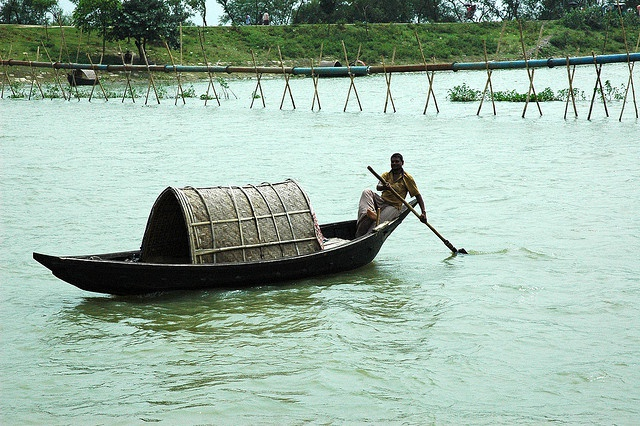Describe the objects in this image and their specific colors. I can see boat in gray, black, ivory, and darkgray tones, people in gray, black, ivory, and olive tones, boat in gray, black, darkgray, and darkgreen tones, people in gray, black, darkgray, and darkgreen tones, and people in gray and black tones in this image. 